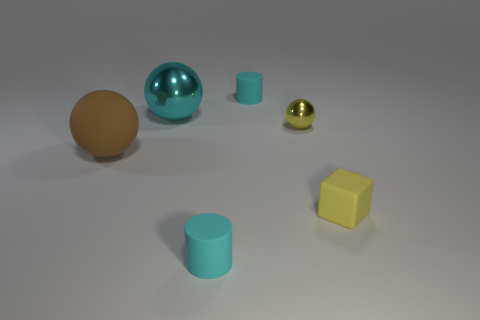Is the small block the same color as the small shiny object?
Give a very brief answer. Yes. Does the metallic thing that is behind the tiny yellow shiny ball have the same shape as the yellow metal object?
Make the answer very short. Yes. What number of other things are the same shape as the big metal object?
Keep it short and to the point. 2. What is the shape of the brown matte object to the left of the tiny yellow sphere?
Your answer should be very brief. Sphere. Is there a blue thing made of the same material as the large cyan thing?
Offer a terse response. No. Is the color of the cylinder in front of the brown ball the same as the big shiny object?
Make the answer very short. Yes. The cyan metallic thing has what size?
Offer a very short reply. Large. Is there a big matte thing on the left side of the large ball to the right of the big sphere that is in front of the big cyan metallic thing?
Make the answer very short. Yes. How many big balls are to the left of the yellow shiny object?
Your answer should be compact. 2. How many matte things have the same color as the large metal thing?
Provide a succinct answer. 2. 